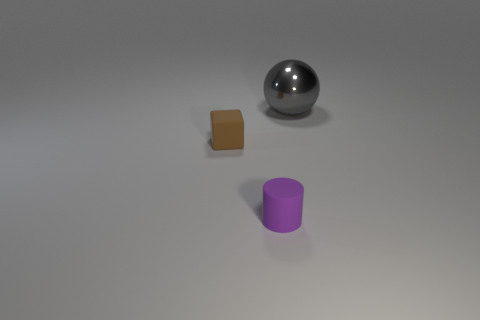Is there any other thing that is the same material as the tiny cylinder?
Offer a very short reply. Yes. Is the number of brown matte blocks left of the small brown rubber thing less than the number of shiny things?
Keep it short and to the point. Yes. Does the small rubber object that is behind the small purple cylinder have the same shape as the big gray metal object?
Keep it short and to the point. No. The object that is the same material as the small purple cylinder is what size?
Offer a terse response. Small. The object that is in front of the tiny rubber object that is behind the tiny rubber object right of the tiny cube is made of what material?
Keep it short and to the point. Rubber. Is the number of big gray metal spheres less than the number of gray rubber balls?
Make the answer very short. No. Do the cylinder and the tiny brown object have the same material?
Make the answer very short. Yes. How many things are in front of the metal thing that is behind the purple cylinder?
Your answer should be very brief. 2. The matte cylinder that is the same size as the cube is what color?
Provide a short and direct response. Purple. What is the object in front of the brown matte cube made of?
Offer a terse response. Rubber. 